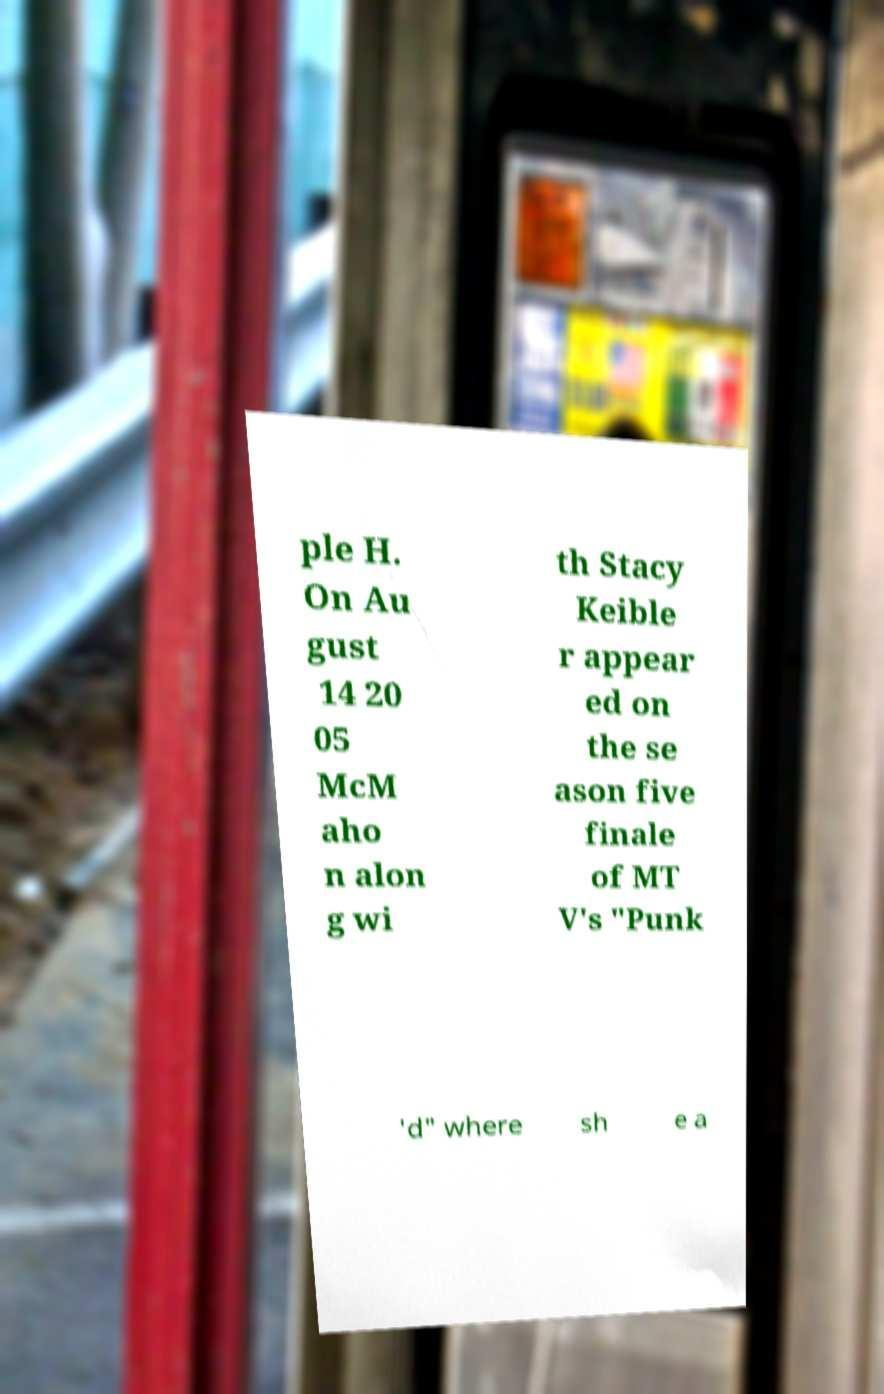Could you extract and type out the text from this image? ple H. On Au gust 14 20 05 McM aho n alon g wi th Stacy Keible r appear ed on the se ason five finale of MT V's "Punk 'd" where sh e a 